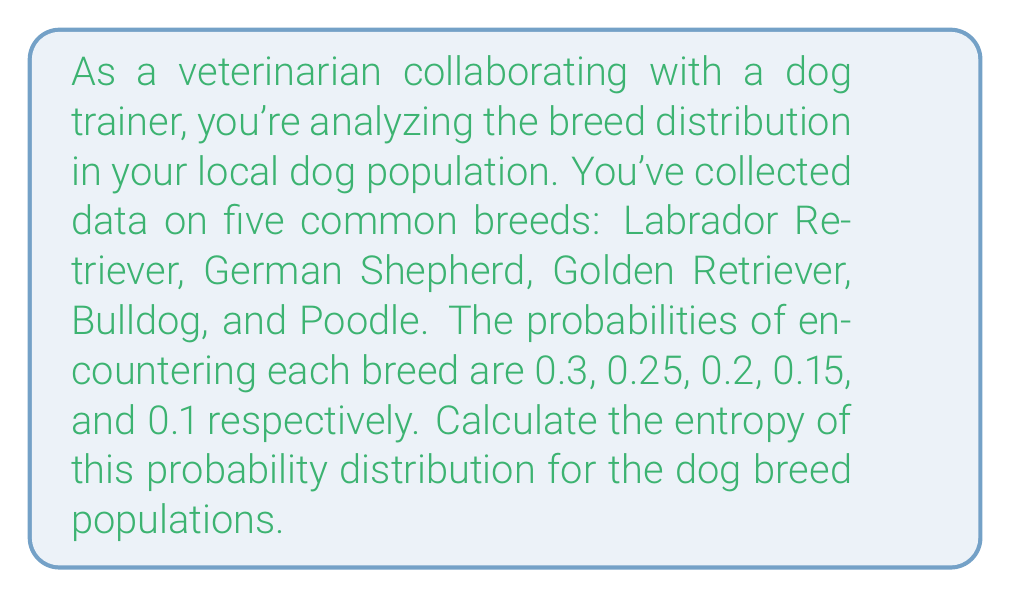Teach me how to tackle this problem. To calculate the entropy of a probability distribution, we use the formula:

$$ H = -\sum_{i=1}^n p_i \log_2(p_i) $$

Where:
- $H$ is the entropy
- $p_i$ is the probability of each event
- $n$ is the number of possible events

Let's calculate for each breed:

1. Labrador Retriever: $p_1 = 0.3$
   $-0.3 \log_2(0.3) = 0.3 \times 1.737 = 0.5211$

2. German Shepherd: $p_2 = 0.25$
   $-0.25 \log_2(0.25) = 0.25 \times 2 = 0.5$

3. Golden Retriever: $p_3 = 0.2$
   $-0.2 \log_2(0.2) = 0.2 \times 2.322 = 0.4644$

4. Bulldog: $p_4 = 0.15$
   $-0.15 \log_2(0.15) = 0.15 \times 2.737 = 0.4106$

5. Poodle: $p_5 = 0.1$
   $-0.1 \log_2(0.1) = 0.1 \times 3.322 = 0.3322$

Now, sum all these values:

$$ H = 0.5211 + 0.5 + 0.4644 + 0.4106 + 0.3322 = 2.2283 $$

The entropy is approximately 2.2283 bits.
Answer: $$ H \approx 2.2283 \text{ bits} $$ 